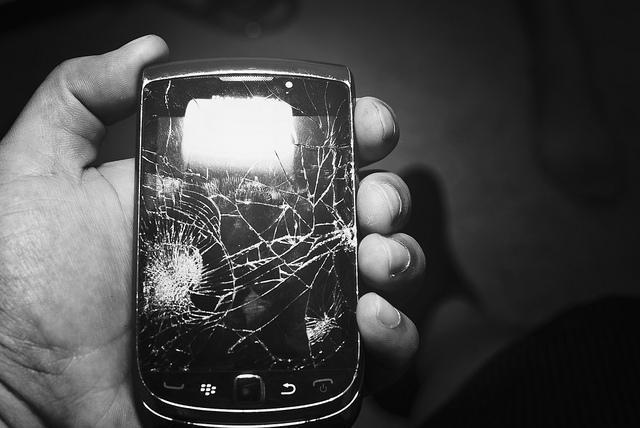How many snowboards are in this scene?
Give a very brief answer. 0. 